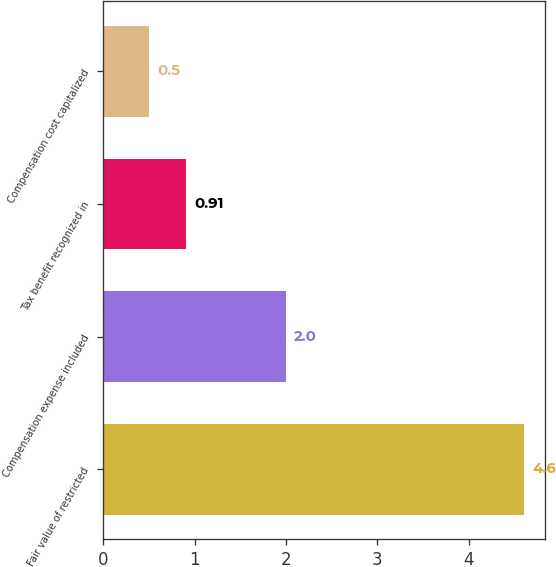Convert chart to OTSL. <chart><loc_0><loc_0><loc_500><loc_500><bar_chart><fcel>Fair value of restricted<fcel>Compensation expense included<fcel>Tax benefit recognized in<fcel>Compensation cost capitalized<nl><fcel>4.6<fcel>2<fcel>0.91<fcel>0.5<nl></chart> 